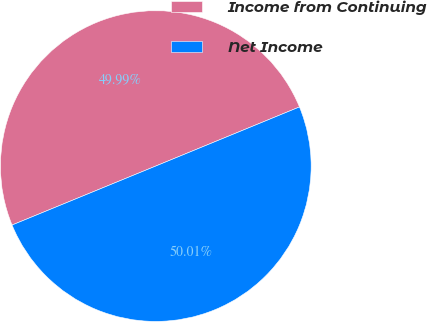Convert chart to OTSL. <chart><loc_0><loc_0><loc_500><loc_500><pie_chart><fcel>Income from Continuing<fcel>Net Income<nl><fcel>49.99%<fcel>50.01%<nl></chart> 